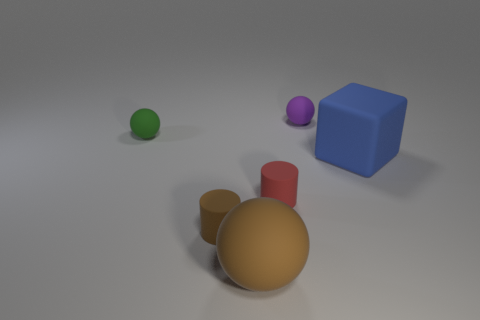Do the objects cast shadows, and what can that tell us about the light source? Yes, each object in the image casts a shadow, which indicates the presence of a light source. The shadows are somewhat soft and spread out rather than sharply defined, suggesting that the light source, while directional, is not extremely close to the objects. This soft shadow effect can often be seen when the light source is slightly diffused or there are multiple light sources contributing to the overall illumination. 